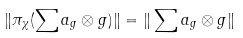<formula> <loc_0><loc_0><loc_500><loc_500>\| \pi _ { \chi } ( \sum a _ { g } \otimes g ) \| = \| \sum a _ { g } \otimes g \|</formula> 